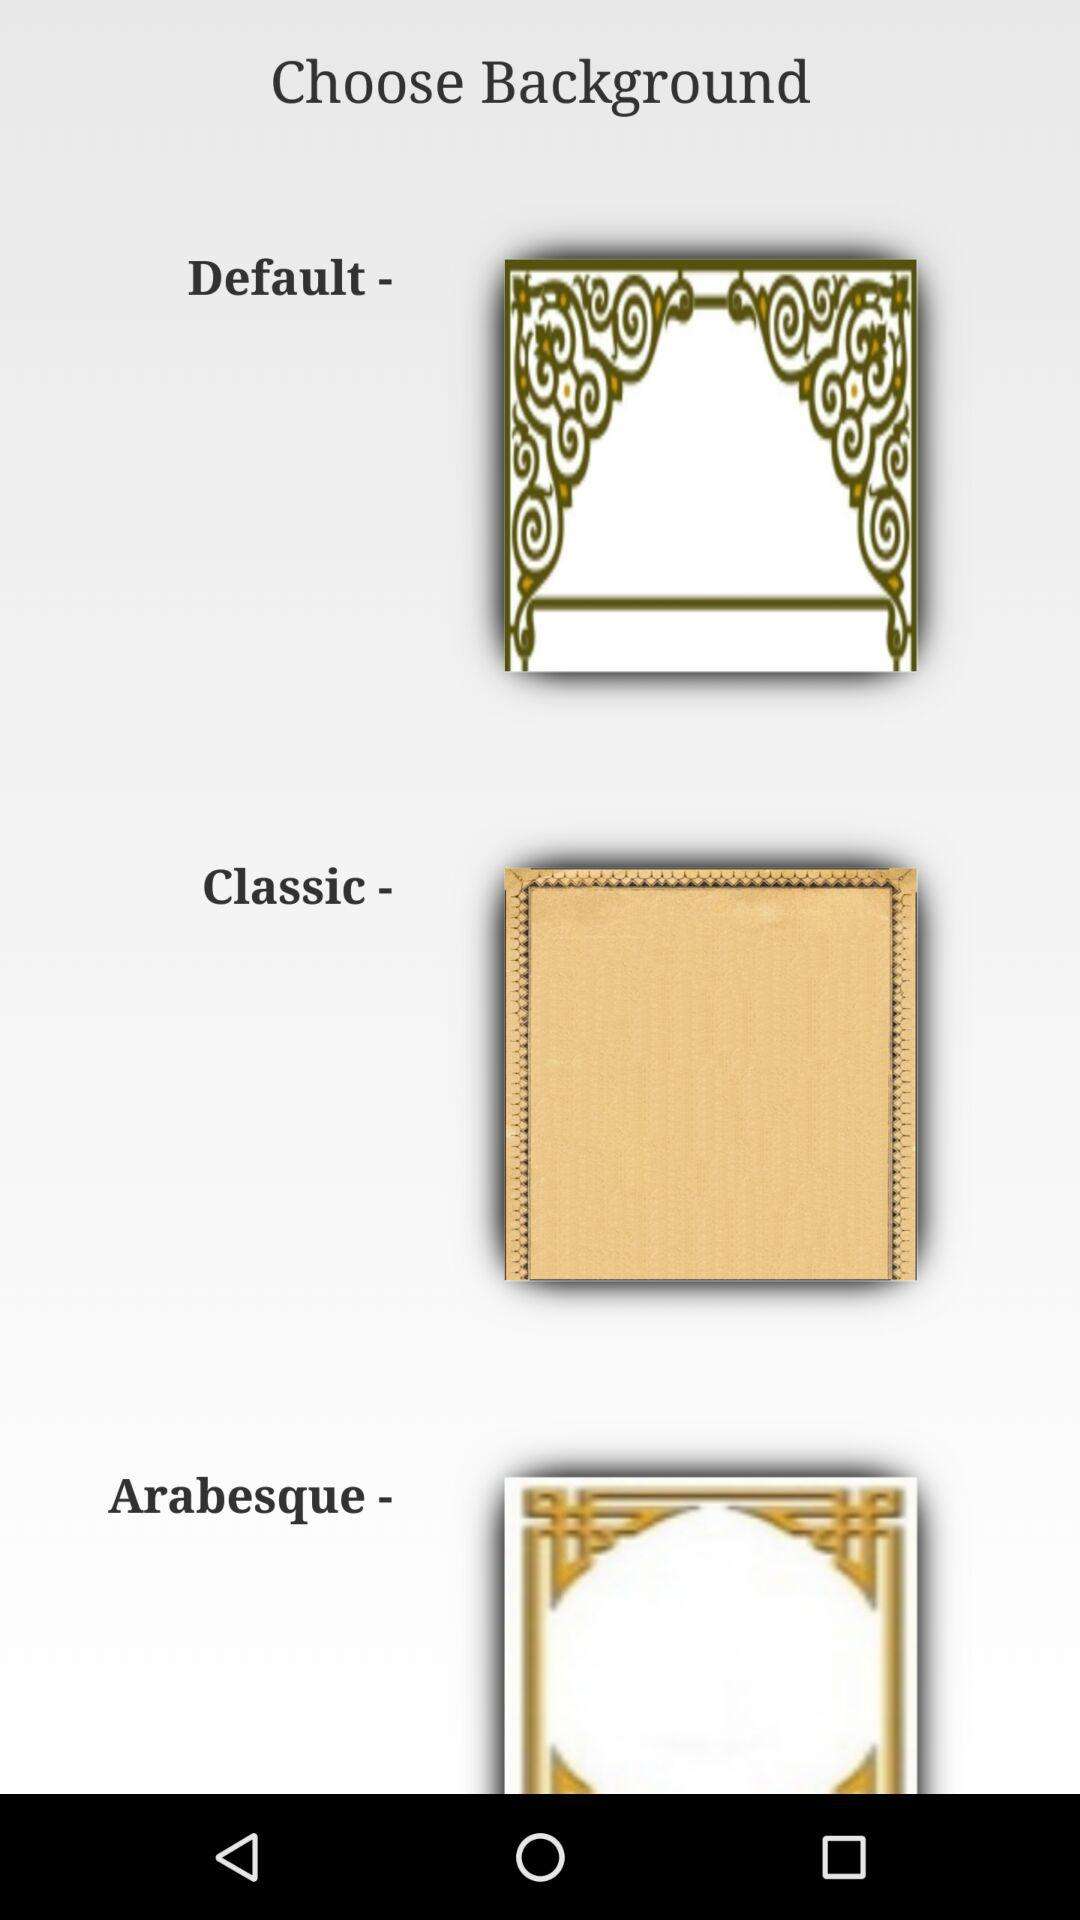How many background options are there?
Answer the question using a single word or phrase. 3 